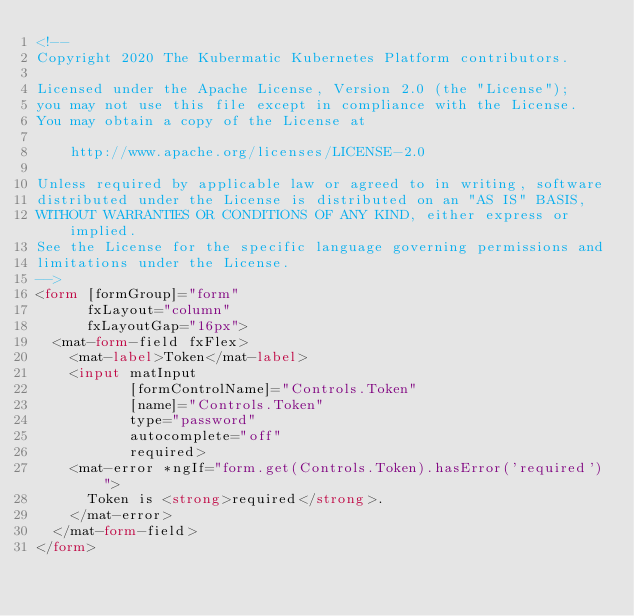<code> <loc_0><loc_0><loc_500><loc_500><_HTML_><!--
Copyright 2020 The Kubermatic Kubernetes Platform contributors.

Licensed under the Apache License, Version 2.0 (the "License");
you may not use this file except in compliance with the License.
You may obtain a copy of the License at

    http://www.apache.org/licenses/LICENSE-2.0

Unless required by applicable law or agreed to in writing, software
distributed under the License is distributed on an "AS IS" BASIS,
WITHOUT WARRANTIES OR CONDITIONS OF ANY KIND, either express or implied.
See the License for the specific language governing permissions and
limitations under the License.
-->
<form [formGroup]="form"
      fxLayout="column"
      fxLayoutGap="16px">
  <mat-form-field fxFlex>
    <mat-label>Token</mat-label>
    <input matInput
           [formControlName]="Controls.Token"
           [name]="Controls.Token"
           type="password"
           autocomplete="off"
           required>
    <mat-error *ngIf="form.get(Controls.Token).hasError('required')">
      Token is <strong>required</strong>.
    </mat-error>
  </mat-form-field>
</form>
</code> 